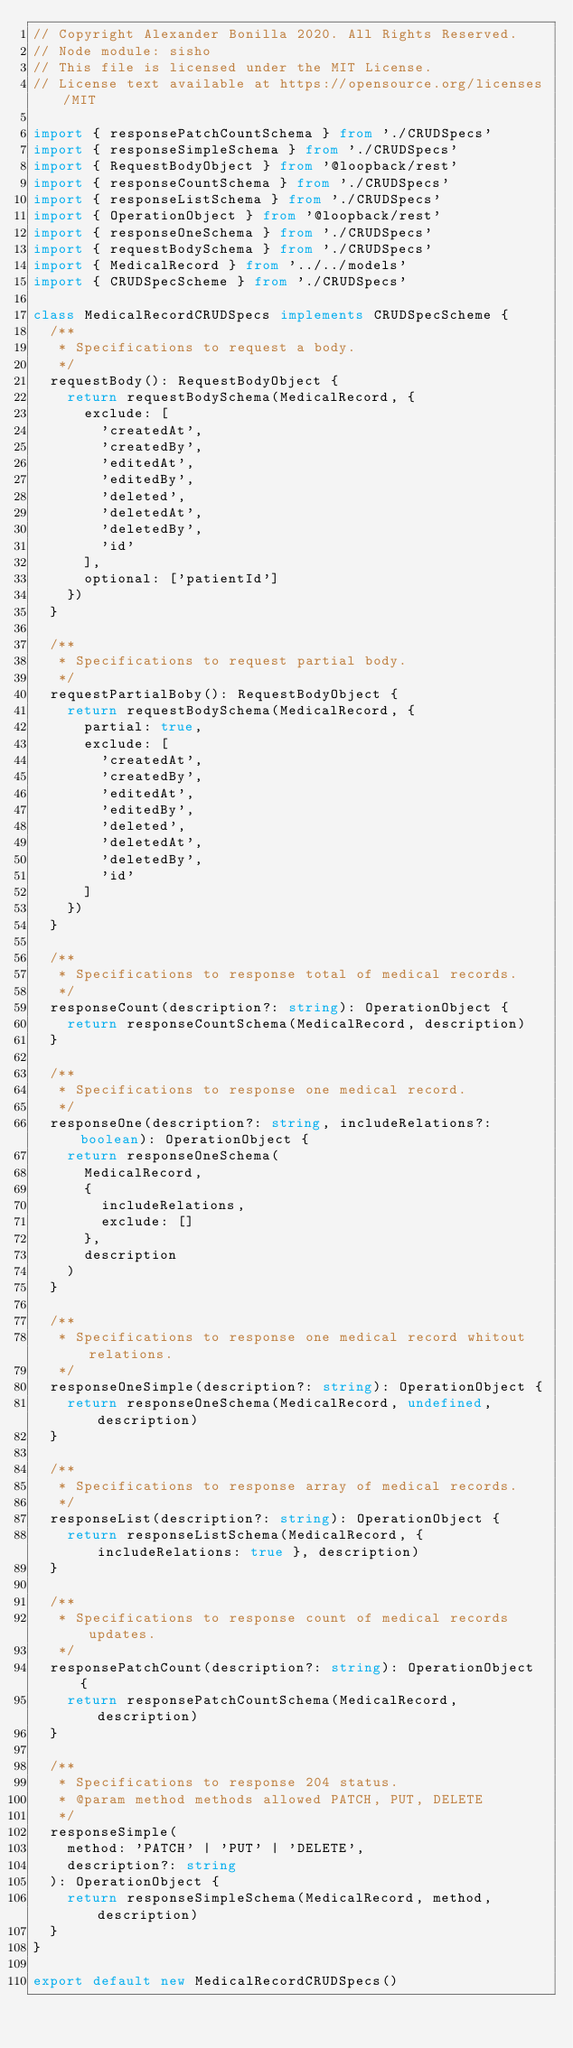Convert code to text. <code><loc_0><loc_0><loc_500><loc_500><_TypeScript_>// Copyright Alexander Bonilla 2020. All Rights Reserved.
// Node module: sisho
// This file is licensed under the MIT License.
// License text available at https://opensource.org/licenses/MIT

import { responsePatchCountSchema } from './CRUDSpecs'
import { responseSimpleSchema } from './CRUDSpecs'
import { RequestBodyObject } from '@loopback/rest'
import { responseCountSchema } from './CRUDSpecs'
import { responseListSchema } from './CRUDSpecs'
import { OperationObject } from '@loopback/rest'
import { responseOneSchema } from './CRUDSpecs'
import { requestBodySchema } from './CRUDSpecs'
import { MedicalRecord } from '../../models'
import { CRUDSpecScheme } from './CRUDSpecs'

class MedicalRecordCRUDSpecs implements CRUDSpecScheme {
  /**
   * Specifications to request a body.
   */
  requestBody(): RequestBodyObject {
    return requestBodySchema(MedicalRecord, {
      exclude: [
        'createdAt',
        'createdBy',
        'editedAt',
        'editedBy',
        'deleted',
        'deletedAt',
        'deletedBy',
        'id'
      ],
      optional: ['patientId']
    })
  }

  /**
   * Specifications to request partial body.
   */
  requestPartialBoby(): RequestBodyObject {
    return requestBodySchema(MedicalRecord, {
      partial: true,
      exclude: [
        'createdAt',
        'createdBy',
        'editedAt',
        'editedBy',
        'deleted',
        'deletedAt',
        'deletedBy',
        'id'
      ]
    })
  }

  /**
   * Specifications to response total of medical records.
   */
  responseCount(description?: string): OperationObject {
    return responseCountSchema(MedicalRecord, description)
  }

  /**
   * Specifications to response one medical record.
   */
  responseOne(description?: string, includeRelations?: boolean): OperationObject {
    return responseOneSchema(
      MedicalRecord,
      {
        includeRelations,
        exclude: []
      },
      description
    )
  }

  /**
   * Specifications to response one medical record whitout relations.
   */
  responseOneSimple(description?: string): OperationObject {
    return responseOneSchema(MedicalRecord, undefined, description)
  }

  /**
   * Specifications to response array of medical records.
   */
  responseList(description?: string): OperationObject {
    return responseListSchema(MedicalRecord, { includeRelations: true }, description)
  }

  /**
   * Specifications to response count of medical records updates.
   */
  responsePatchCount(description?: string): OperationObject {
    return responsePatchCountSchema(MedicalRecord, description)
  }

  /**
   * Specifications to response 204 status.
   * @param method methods allowed PATCH, PUT, DELETE
   */
  responseSimple(
    method: 'PATCH' | 'PUT' | 'DELETE',
    description?: string
  ): OperationObject {
    return responseSimpleSchema(MedicalRecord, method, description)
  }
}

export default new MedicalRecordCRUDSpecs()
</code> 